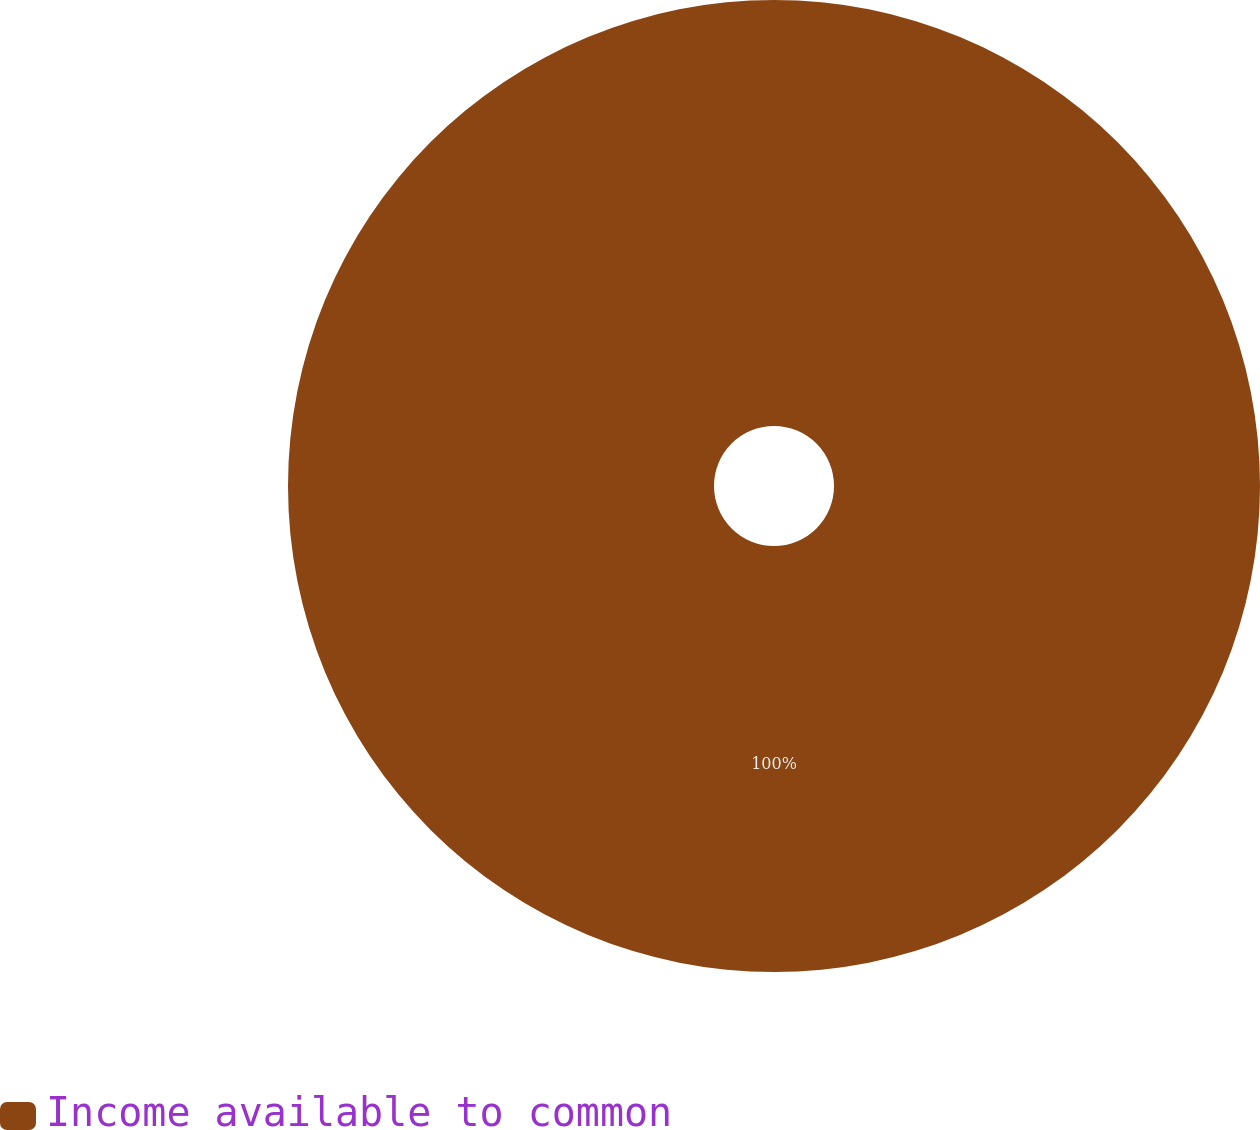<chart> <loc_0><loc_0><loc_500><loc_500><pie_chart><fcel>Income available to common<nl><fcel>100.0%<nl></chart> 